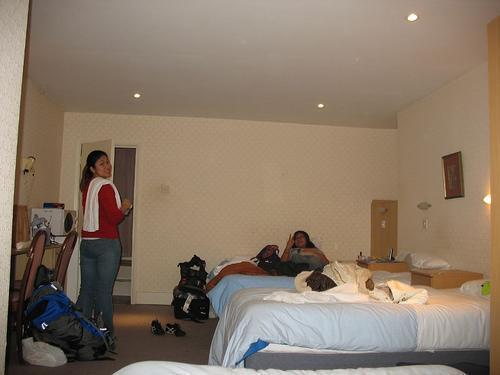How many beds are in the room?
Give a very brief answer. 2. How many cups are to the right of the plate?
Give a very brief answer. 0. 